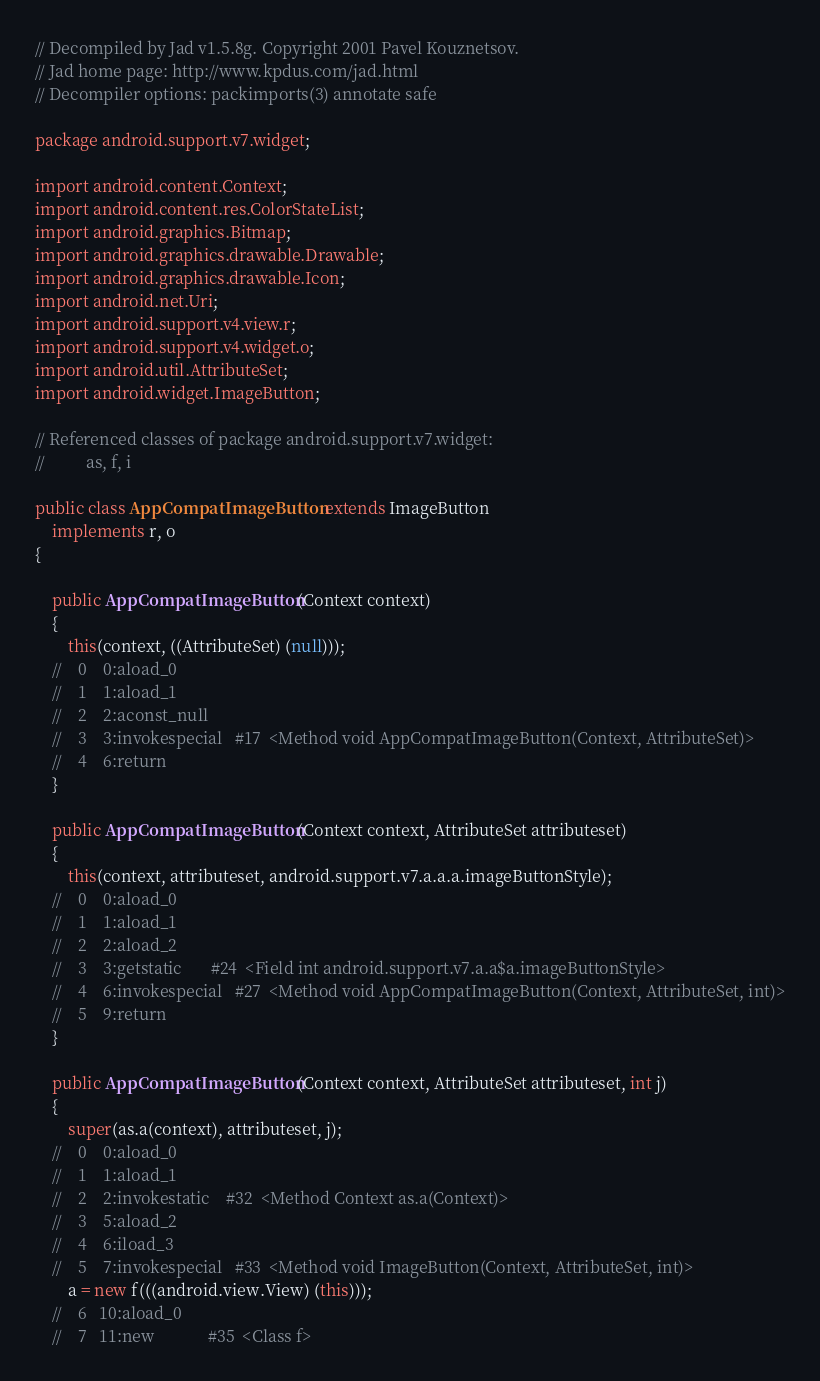<code> <loc_0><loc_0><loc_500><loc_500><_Java_>// Decompiled by Jad v1.5.8g. Copyright 2001 Pavel Kouznetsov.
// Jad home page: http://www.kpdus.com/jad.html
// Decompiler options: packimports(3) annotate safe 

package android.support.v7.widget;

import android.content.Context;
import android.content.res.ColorStateList;
import android.graphics.Bitmap;
import android.graphics.drawable.Drawable;
import android.graphics.drawable.Icon;
import android.net.Uri;
import android.support.v4.view.r;
import android.support.v4.widget.o;
import android.util.AttributeSet;
import android.widget.ImageButton;

// Referenced classes of package android.support.v7.widget:
//			as, f, i

public class AppCompatImageButton extends ImageButton
	implements r, o
{

	public AppCompatImageButton(Context context)
	{
		this(context, ((AttributeSet) (null)));
	//    0    0:aload_0         
	//    1    1:aload_1         
	//    2    2:aconst_null     
	//    3    3:invokespecial   #17  <Method void AppCompatImageButton(Context, AttributeSet)>
	//    4    6:return          
	}

	public AppCompatImageButton(Context context, AttributeSet attributeset)
	{
		this(context, attributeset, android.support.v7.a.a.a.imageButtonStyle);
	//    0    0:aload_0         
	//    1    1:aload_1         
	//    2    2:aload_2         
	//    3    3:getstatic       #24  <Field int android.support.v7.a.a$a.imageButtonStyle>
	//    4    6:invokespecial   #27  <Method void AppCompatImageButton(Context, AttributeSet, int)>
	//    5    9:return          
	}

	public AppCompatImageButton(Context context, AttributeSet attributeset, int j)
	{
		super(as.a(context), attributeset, j);
	//    0    0:aload_0         
	//    1    1:aload_1         
	//    2    2:invokestatic    #32  <Method Context as.a(Context)>
	//    3    5:aload_2         
	//    4    6:iload_3         
	//    5    7:invokespecial   #33  <Method void ImageButton(Context, AttributeSet, int)>
		a = new f(((android.view.View) (this)));
	//    6   10:aload_0         
	//    7   11:new             #35  <Class f></code> 